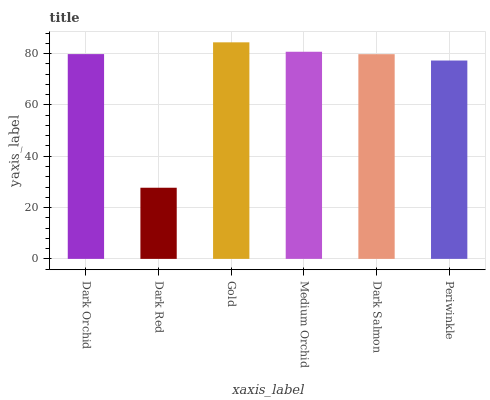Is Dark Red the minimum?
Answer yes or no. Yes. Is Gold the maximum?
Answer yes or no. Yes. Is Gold the minimum?
Answer yes or no. No. Is Dark Red the maximum?
Answer yes or no. No. Is Gold greater than Dark Red?
Answer yes or no. Yes. Is Dark Red less than Gold?
Answer yes or no. Yes. Is Dark Red greater than Gold?
Answer yes or no. No. Is Gold less than Dark Red?
Answer yes or no. No. Is Dark Orchid the high median?
Answer yes or no. Yes. Is Dark Salmon the low median?
Answer yes or no. Yes. Is Dark Salmon the high median?
Answer yes or no. No. Is Medium Orchid the low median?
Answer yes or no. No. 